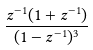<formula> <loc_0><loc_0><loc_500><loc_500>\frac { z ^ { - 1 } ( 1 + z ^ { - 1 } ) } { ( 1 - z ^ { - 1 } ) ^ { 3 } }</formula> 